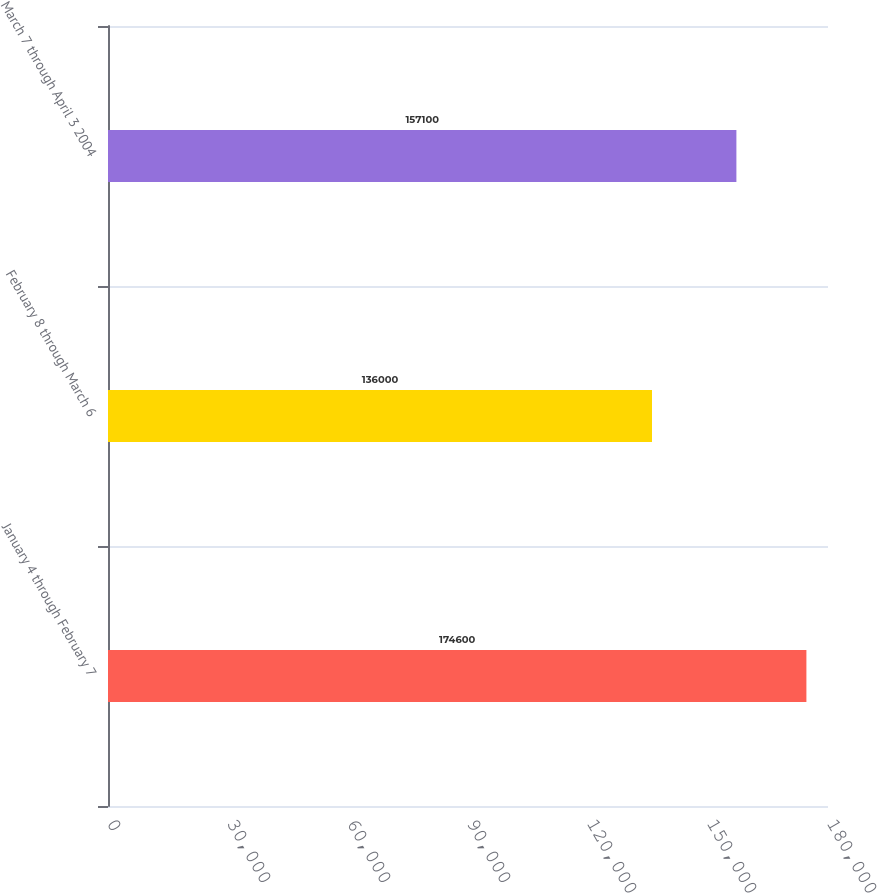<chart> <loc_0><loc_0><loc_500><loc_500><bar_chart><fcel>January 4 through February 7<fcel>February 8 through March 6<fcel>March 7 through April 3 2004<nl><fcel>174600<fcel>136000<fcel>157100<nl></chart> 